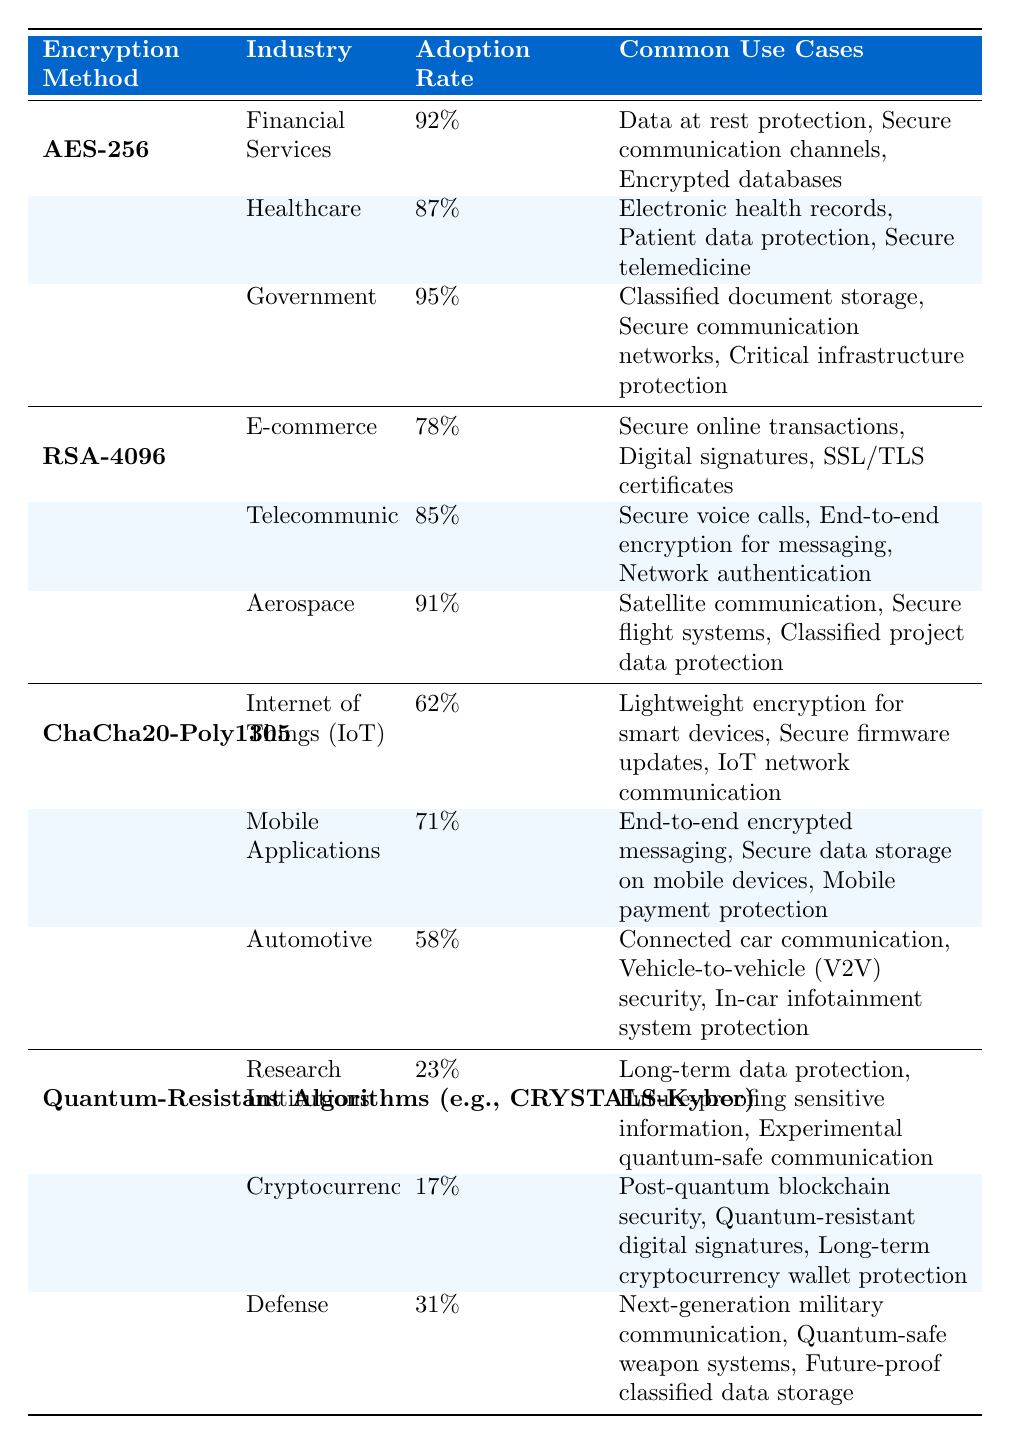What is the adoption rate of AES-256 in Government? The table lists the adoption rate for AES-256 in the Government industry as 95%.
Answer: 95% Which encryption method has the highest adoption rate in the Financial Services industry? According to the table, AES-256 has the highest adoption rate at 92% in the Financial Services industry.
Answer: AES-256 What are the common use cases for RSA-4096 in Telecommunications? The table indicates that the common use cases for RSA-4096 in Telecommunications include secure voice calls, end-to-end encryption for messaging, and network authentication.
Answer: Secure voice calls, end-to-end encryption for messaging, network authentication What is the adoption rate difference between ChaCha20-Poly1305 in Automotive and Healthcare for AES-256? The adoption rate for ChaCha20-Poly1305 in Automotive is 58%, and for AES-256 in Healthcare, it is 87%. The difference is 87% - 58% = 29%.
Answer: 29% Which encryption method has the lowest overall adoption rate? When comparing all adoption rates, Quantum-Resistant Algorithms have the lowest adoption rate at 23% in Research Institutions.
Answer: Quantum-Resistant Algorithms Is the adoption rate of ChaCha20-Poly1305 in IoT industries greater than 60%? The adoption rate of ChaCha20-Poly1305 in the IoT industry is listed as 62%, which is greater than 60%.
Answer: Yes How many industries utilize AES-256 for data at rest protection based on the table? AES-256 is adopted in the Financial Services, Healthcare, and Government industries for data at rest protection, making it three industries.
Answer: 3 What is the average adoption rate for the Quantum-Resistant Algorithms across all listed industries? The adoption rates for the three industries are 23%, 17%, and 31%. The average is calculated as (23 + 17 + 31) / 3 = 23.67%.
Answer: 23.67% Which encryption method has a higher adoption rate in Aerospace compared to E-commerce? The adoption rate for RSA-4096 in Aerospace is 91%, while E-commerce has 78%. Since 91% > 78%, RSA-4096 has a higher adoption rate in Aerospace.
Answer: RSA-4096 What is the total number of industries utilizing the encryption method with the highest adoption rates? The encryption method with the highest adoption rates is AES-256, which is utilized in three industries: Financial Services, Healthcare, and Government. Therefore, the total is 3.
Answer: 3 